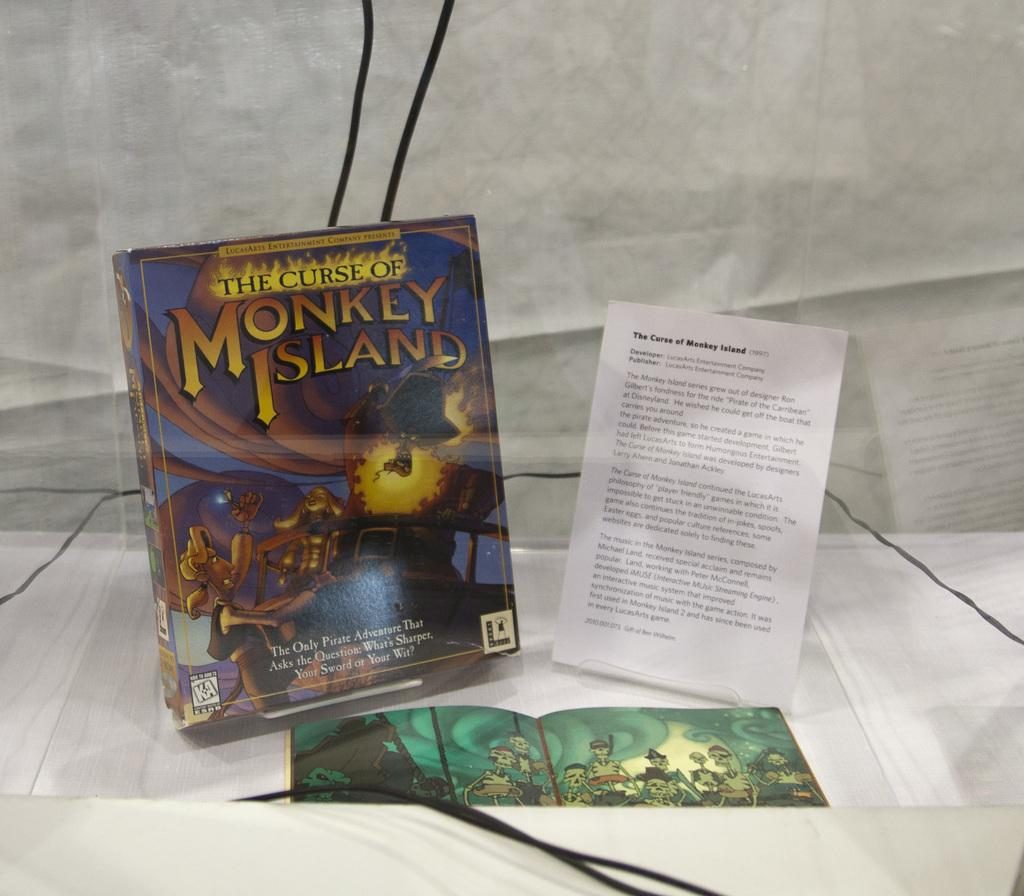What type of objects can be seen in the image? There are books and a paper on the table in the image. Are there any visible wires in the image? Yes, there are wires visible in the image. What might be used for reflecting or checking appearance in the image? There appears to be a mirror in the image. How many fangs can be seen on the toad in the image? There is no toad present in the image, so there are no fangs to count. 